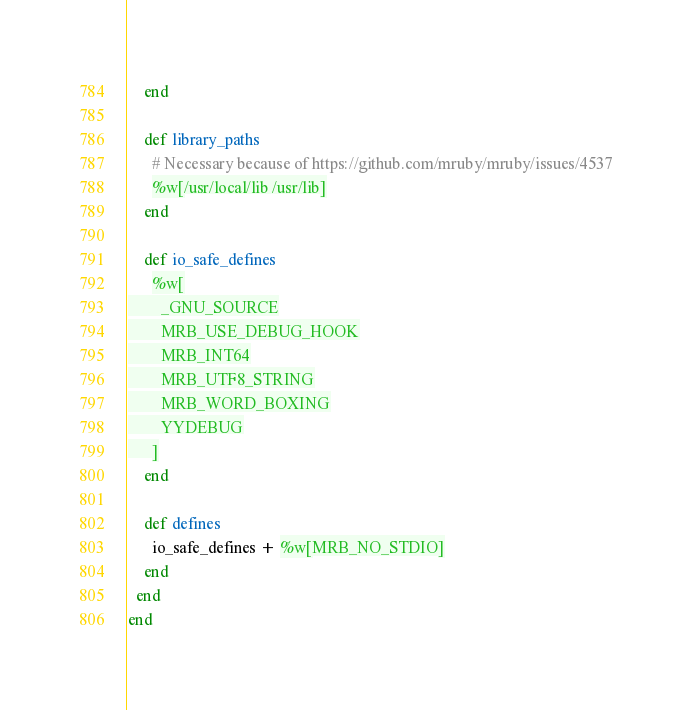Convert code to text. <code><loc_0><loc_0><loc_500><loc_500><_Ruby_>    end

    def library_paths
      # Necessary because of https://github.com/mruby/mruby/issues/4537
      %w[/usr/local/lib /usr/lib]
    end

    def io_safe_defines
      %w[
        _GNU_SOURCE
        MRB_USE_DEBUG_HOOK
        MRB_INT64
        MRB_UTF8_STRING
        MRB_WORD_BOXING
        YYDEBUG
      ]
    end

    def defines
      io_safe_defines + %w[MRB_NO_STDIO]
    end
  end
end
</code> 